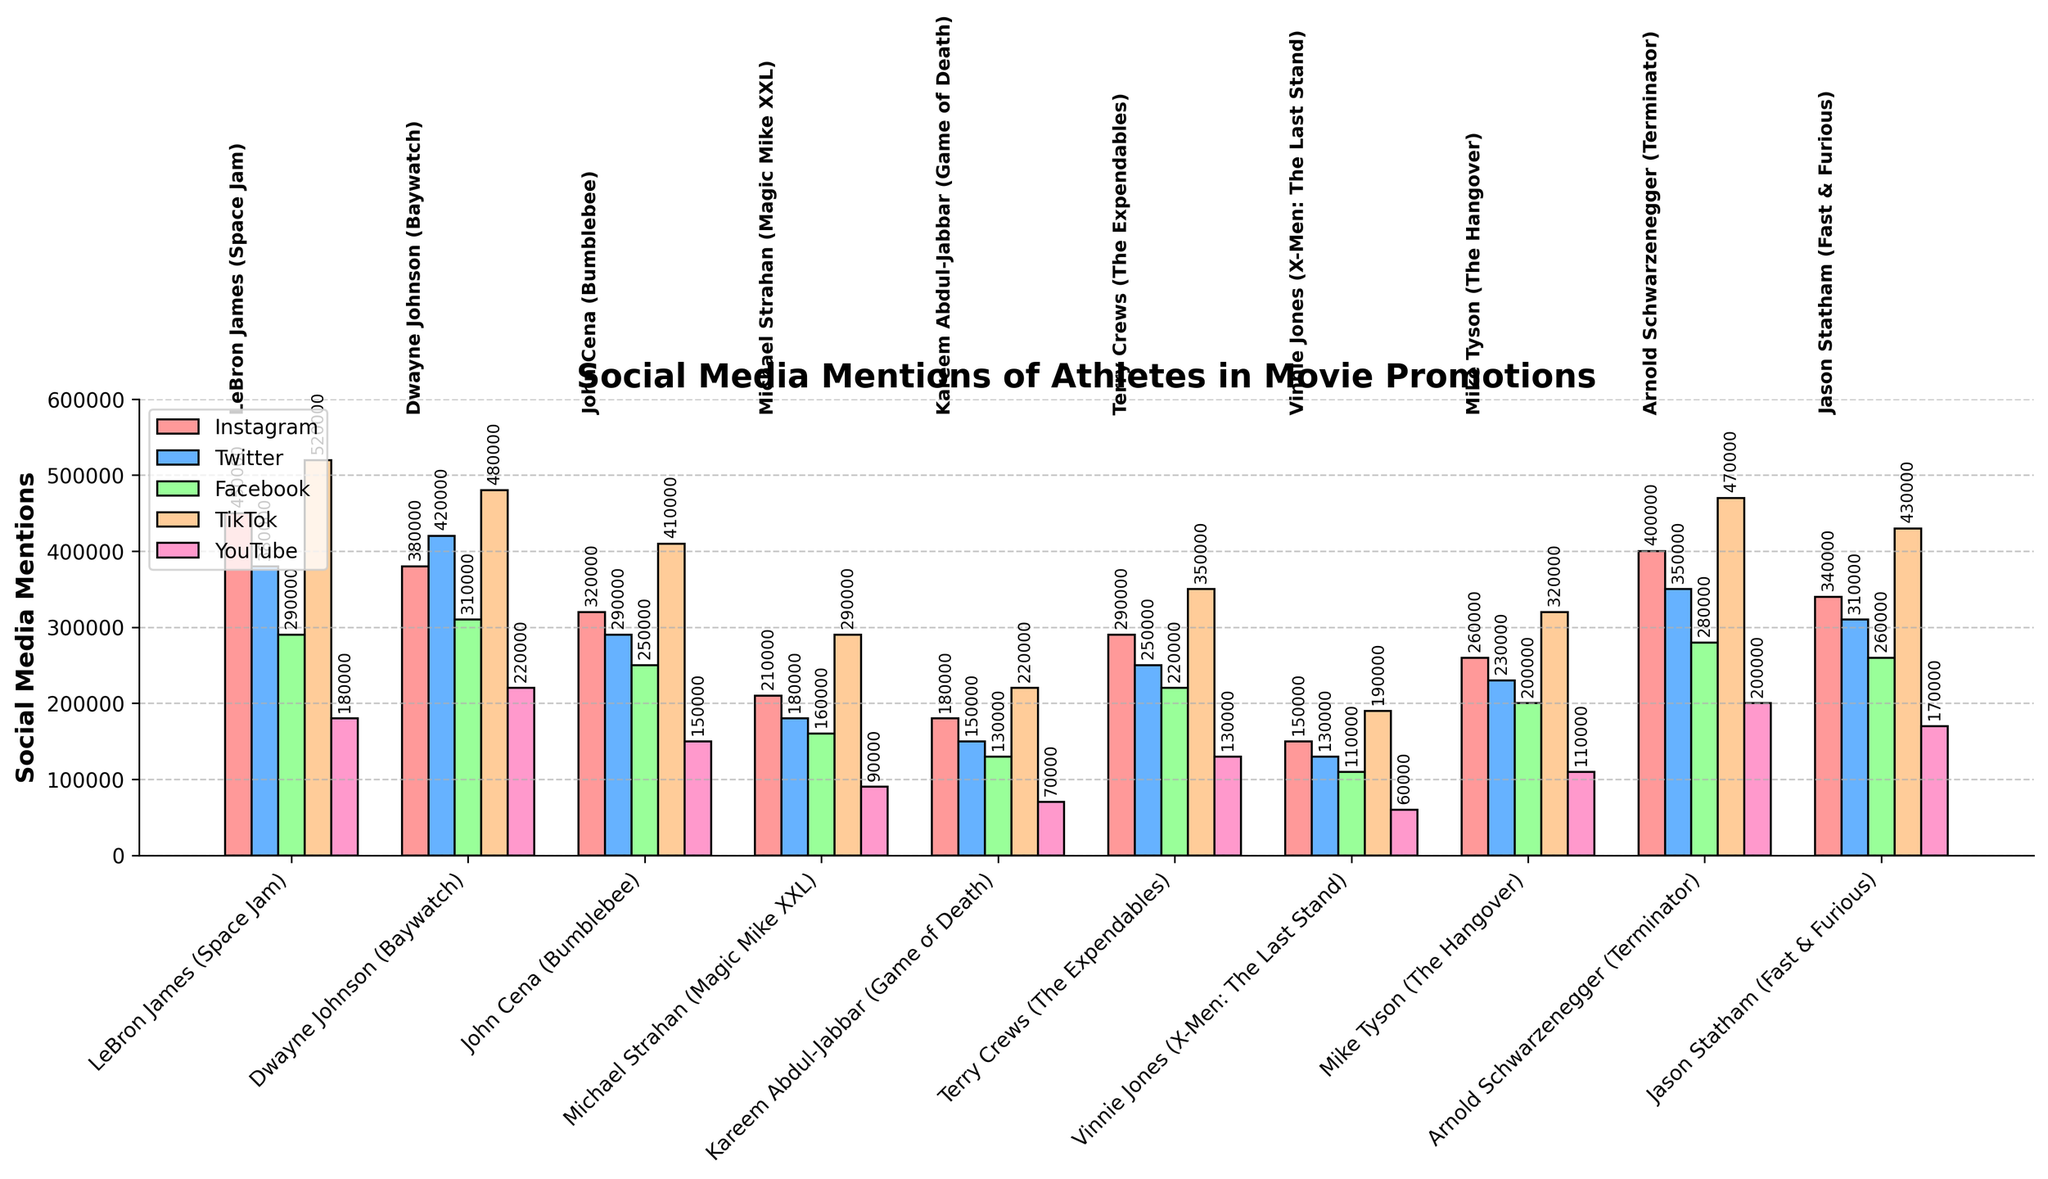Which athlete received the most mentions on TikTok? The tallest bar in the TikTok section corresponds to LeBron James, indicating that he received the most mentions on TikTok.
Answer: LeBron James Which platform had the least mentions for Michael Strahan? By comparing the height of the bars for Michael Strahan, the Facebook bar is the shortest, indicating it had the least mentions.
Answer: Facebook How many total mentions did Terry Crews receive across all platforms? Add the mentions from each platform for Terry Crews: 290000 (Instagram) + 250000 (Twitter) + 220000 (Facebook) + 350000 (TikTok) + 130000 (YouTube).
Answer: 1240000 Which athlete has more mentions on Instagram, Jason Statham or Dwayne Johnson? Compare the height of the Instagram bars for Jason Statham and Dwayne Johnson, where Jason Statham's bar is slightly taller.
Answer: Jason Statham What is the difference in mentions on Twitter between Arnold Schwarzenegger and Kareem Abdul-Jabbar? Subtract Kareem Abdul-Jabbar's Twitter mentions from Arnold Schwarzenegger's: 350000 - 150000.
Answer: 200000 Among the top three athletes in terms of Instagram mentions (LeBron James, Arnold Schwarzenegger, and Dwayne Johnson), who has the least number of mentions on YouTube? Compare the height of the YouTube bars for LeBron James, Arnold Schwarzenegger, and Dwayne Johnson, with Dwayne Johnson having the highest, LeBron James in the middle, and Arnold Schwarzenegger the lowest.
Answer: Arnold Schwarzenegger Which platform is consistently the highest across all athletes? By visually inspecting the height of bars across all athletes, TikTok bars seem to generally be the tallest.
Answer: TikTok What is the average number of Facebook mentions for John Cena, Terry Crews, and Vinnie Jones? Add the Facebook mentions of John Cena (250000), Terry Crews (220000), and Vinnie Jones (110000) and divide by 3: (250000 + 220000 + 110000) / 3.
Answer: 193333.33 Compare mentions on YouTube for Mike Tyson and Kareem Abdul-Jabbar, who has more? The height of the YouTube bar for Mike Tyson is taller than that of Kareem Abdul-Jabbar.
Answer: Mike Tyson 